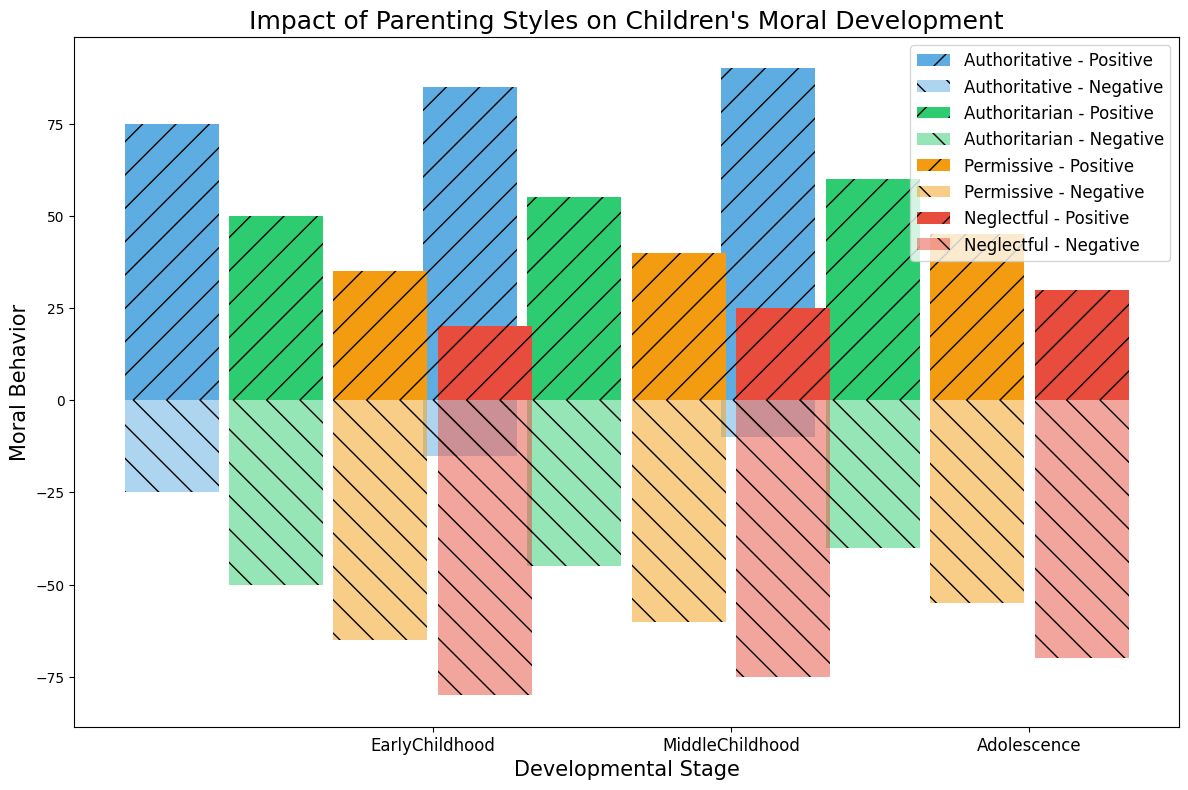What parenting style shows the highest positive moral behavior in adolescence? To find the answer, look at the bars representing adolescence in the positive moral behavior section. The Authoritative bar is the tallest among all the bars representing different parenting styles, indicating it has the highest positive moral behavior.
Answer: Authoritative Which developmental stage shows the greatest difference between positive and negative moral behavior for the authoritative parenting style? Check the differences between the heights of the positive and negative moral behavior bars for all developmental stages within the Authoritative parenting style. Adolescence shows the largest disparity, with a very high positive behavior bar and a very low negative behavior bar.
Answer: Adolescence In early childhood, which parenting style shows the least positive moral behavior? Look at the positive moral behavior bars for the early childhood stage. The Neglectful parenting style has the smallest bar, indicating the least positive moral behavior.
Answer: Neglectful How does the permissive parenting style's negative moral behavior in middle childhood compare to that in early childhood? Compare the negative moral behavior bars for the Permissive parenting style between early and middle childhood. The heights of the bars are 65 in early childhood and 60 in middle childhood, showing a slight decrease in negative moral behavior.
Answer: Decreases What's the average positive moral behavior of the authoritative parenting style across all developmental stages? Add the positive moral behavior values for the authoritative parenting style across all stages: (75 + 85 + 90) = 250. Then, divide this by the number of stages (3) to get the average. 250/3 = 83.33.
Answer: 83.33 For the authoritarian parenting style, which developmental stage shows the highest negative moral behavior? Examine the heights of the negative moral behavior bars for each developmental stage within the Authoritarian parenting style. Early childhood has the highest bar at 50.
Answer: Early childhood Compare the total positive moral behavior values among all parenting styles in adolescence. Which one displays the highest combined value? Sum the positive moral behavior values for each parenting style in adolescence. Authoritative: 90, Authoritarian: 60, Permissive: 45, Neglectful: 30. The Authoritative parenting style has the highest total with 90.
Answer: Authoritative Which parenting style has the smallest difference in positive and negative moral behaviors in middle childhood? For middle childhood, compute the differences between the positive and negative moral behavior values for each parenting style. Authoritative: 85 - 15 = 70, Authoritarian: 55 - 45 = 10, Permissive: 40 - 60 = -20, Neglectful: 25 - 75 = -50. The Authoritarian style has the smallest difference (10).
Answer: Authoritarian What is the trend in positive moral behavior for the authoritarian parenting style from early childhood to adolescence? Track the positive moral behavior values of the authoritarian parenting style from early childhood (50) to middle childhood (55) to adolescence (60) and observe the pattern. It shows a gradual increase.
Answer: Increasing 